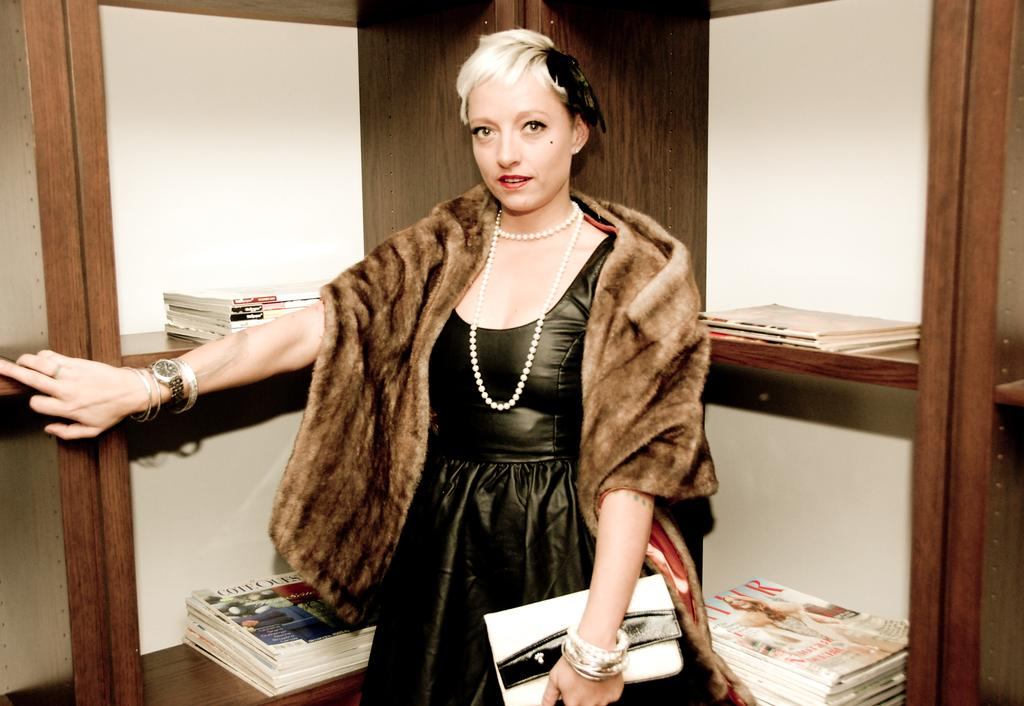Who is present in the image? There is a woman in the image. What is the woman doing in the image? The woman is standing in the image. What is the woman holding in the image? The woman is holding a handbag in the image. What is the woman wearing in the image? The woman is wearing a scarf in the image. What can be seen in the background of the image? There are shelves in the background of the image. What items are on the shelves in the image? There are books and newspapers on the shelves in the image. What type of tent can be seen in the image? There is no tent present in the image. 